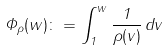Convert formula to latex. <formula><loc_0><loc_0><loc_500><loc_500>\Phi _ { \rho } ( w ) \colon = \int _ { 1 } ^ { w } \frac { 1 } { \rho ( v ) } \, d v</formula> 